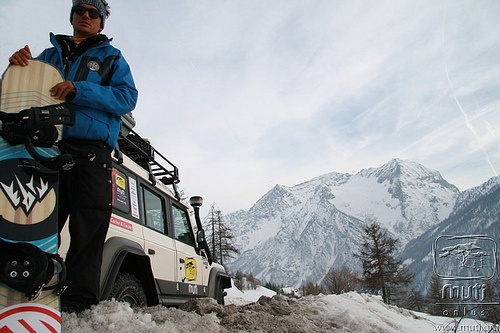Describe the objects in this image and their specific colors. I can see people in darkgray, black, darkblue, blue, and maroon tones, snowboard in darkgray, black, tan, and gray tones, and truck in darkgray, black, gray, and lightgray tones in this image. 